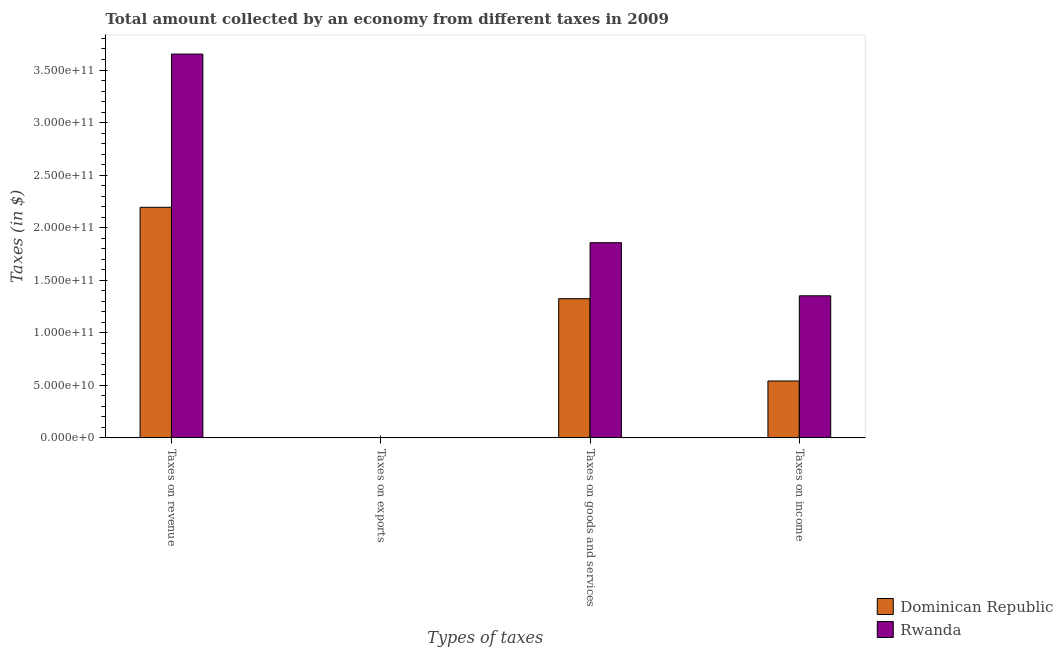How many different coloured bars are there?
Provide a succinct answer. 2. How many groups of bars are there?
Give a very brief answer. 4. Are the number of bars on each tick of the X-axis equal?
Give a very brief answer. Yes. How many bars are there on the 1st tick from the right?
Keep it short and to the point. 2. What is the label of the 1st group of bars from the left?
Provide a short and direct response. Taxes on revenue. What is the amount collected as tax on goods in Rwanda?
Provide a short and direct response. 1.86e+11. Across all countries, what is the maximum amount collected as tax on exports?
Your answer should be compact. 1.32e+08. Across all countries, what is the minimum amount collected as tax on income?
Your response must be concise. 5.41e+1. In which country was the amount collected as tax on revenue maximum?
Your response must be concise. Rwanda. In which country was the amount collected as tax on goods minimum?
Provide a short and direct response. Dominican Republic. What is the total amount collected as tax on income in the graph?
Provide a succinct answer. 1.89e+11. What is the difference between the amount collected as tax on goods in Dominican Republic and that in Rwanda?
Keep it short and to the point. -5.33e+1. What is the difference between the amount collected as tax on revenue in Dominican Republic and the amount collected as tax on exports in Rwanda?
Provide a short and direct response. 2.19e+11. What is the average amount collected as tax on revenue per country?
Your answer should be compact. 2.92e+11. What is the difference between the amount collected as tax on exports and amount collected as tax on income in Rwanda?
Make the answer very short. -1.35e+11. In how many countries, is the amount collected as tax on revenue greater than 120000000000 $?
Your answer should be compact. 2. What is the ratio of the amount collected as tax on revenue in Dominican Republic to that in Rwanda?
Provide a succinct answer. 0.6. Is the amount collected as tax on income in Rwanda less than that in Dominican Republic?
Keep it short and to the point. No. Is the difference between the amount collected as tax on income in Dominican Republic and Rwanda greater than the difference between the amount collected as tax on goods in Dominican Republic and Rwanda?
Provide a succinct answer. No. What is the difference between the highest and the second highest amount collected as tax on income?
Offer a terse response. 8.11e+1. What is the difference between the highest and the lowest amount collected as tax on goods?
Offer a very short reply. 5.33e+1. Is the sum of the amount collected as tax on goods in Rwanda and Dominican Republic greater than the maximum amount collected as tax on revenue across all countries?
Provide a succinct answer. No. Is it the case that in every country, the sum of the amount collected as tax on revenue and amount collected as tax on income is greater than the sum of amount collected as tax on goods and amount collected as tax on exports?
Offer a terse response. No. What does the 2nd bar from the left in Taxes on income represents?
Offer a very short reply. Rwanda. What does the 2nd bar from the right in Taxes on income represents?
Offer a very short reply. Dominican Republic. How many bars are there?
Offer a very short reply. 8. What is the difference between two consecutive major ticks on the Y-axis?
Your answer should be compact. 5.00e+1. Does the graph contain any zero values?
Provide a succinct answer. No. Where does the legend appear in the graph?
Your answer should be very brief. Bottom right. How are the legend labels stacked?
Your answer should be compact. Vertical. What is the title of the graph?
Offer a very short reply. Total amount collected by an economy from different taxes in 2009. Does "St. Martin (French part)" appear as one of the legend labels in the graph?
Ensure brevity in your answer.  No. What is the label or title of the X-axis?
Provide a short and direct response. Types of taxes. What is the label or title of the Y-axis?
Your answer should be compact. Taxes (in $). What is the Taxes (in $) in Dominican Republic in Taxes on revenue?
Your response must be concise. 2.19e+11. What is the Taxes (in $) in Rwanda in Taxes on revenue?
Keep it short and to the point. 3.65e+11. What is the Taxes (in $) in Dominican Republic in Taxes on exports?
Your response must be concise. 1.32e+08. What is the Taxes (in $) in Rwanda in Taxes on exports?
Your response must be concise. 1.73e+07. What is the Taxes (in $) in Dominican Republic in Taxes on goods and services?
Offer a very short reply. 1.32e+11. What is the Taxes (in $) of Rwanda in Taxes on goods and services?
Ensure brevity in your answer.  1.86e+11. What is the Taxes (in $) of Dominican Republic in Taxes on income?
Your response must be concise. 5.41e+1. What is the Taxes (in $) of Rwanda in Taxes on income?
Provide a short and direct response. 1.35e+11. Across all Types of taxes, what is the maximum Taxes (in $) of Dominican Republic?
Your response must be concise. 2.19e+11. Across all Types of taxes, what is the maximum Taxes (in $) in Rwanda?
Keep it short and to the point. 3.65e+11. Across all Types of taxes, what is the minimum Taxes (in $) of Dominican Republic?
Your answer should be compact. 1.32e+08. Across all Types of taxes, what is the minimum Taxes (in $) of Rwanda?
Provide a succinct answer. 1.73e+07. What is the total Taxes (in $) of Dominican Republic in the graph?
Your answer should be compact. 4.06e+11. What is the total Taxes (in $) of Rwanda in the graph?
Keep it short and to the point. 6.86e+11. What is the difference between the Taxes (in $) of Dominican Republic in Taxes on revenue and that in Taxes on exports?
Ensure brevity in your answer.  2.19e+11. What is the difference between the Taxes (in $) of Rwanda in Taxes on revenue and that in Taxes on exports?
Offer a very short reply. 3.65e+11. What is the difference between the Taxes (in $) of Dominican Republic in Taxes on revenue and that in Taxes on goods and services?
Ensure brevity in your answer.  8.70e+1. What is the difference between the Taxes (in $) in Rwanda in Taxes on revenue and that in Taxes on goods and services?
Your answer should be compact. 1.79e+11. What is the difference between the Taxes (in $) of Dominican Republic in Taxes on revenue and that in Taxes on income?
Ensure brevity in your answer.  1.65e+11. What is the difference between the Taxes (in $) in Rwanda in Taxes on revenue and that in Taxes on income?
Your answer should be very brief. 2.30e+11. What is the difference between the Taxes (in $) of Dominican Republic in Taxes on exports and that in Taxes on goods and services?
Keep it short and to the point. -1.32e+11. What is the difference between the Taxes (in $) of Rwanda in Taxes on exports and that in Taxes on goods and services?
Make the answer very short. -1.86e+11. What is the difference between the Taxes (in $) in Dominican Republic in Taxes on exports and that in Taxes on income?
Keep it short and to the point. -5.40e+1. What is the difference between the Taxes (in $) of Rwanda in Taxes on exports and that in Taxes on income?
Ensure brevity in your answer.  -1.35e+11. What is the difference between the Taxes (in $) of Dominican Republic in Taxes on goods and services and that in Taxes on income?
Your answer should be very brief. 7.83e+1. What is the difference between the Taxes (in $) in Rwanda in Taxes on goods and services and that in Taxes on income?
Ensure brevity in your answer.  5.05e+1. What is the difference between the Taxes (in $) in Dominican Republic in Taxes on revenue and the Taxes (in $) in Rwanda in Taxes on exports?
Ensure brevity in your answer.  2.19e+11. What is the difference between the Taxes (in $) in Dominican Republic in Taxes on revenue and the Taxes (in $) in Rwanda in Taxes on goods and services?
Make the answer very short. 3.37e+1. What is the difference between the Taxes (in $) of Dominican Republic in Taxes on revenue and the Taxes (in $) of Rwanda in Taxes on income?
Ensure brevity in your answer.  8.42e+1. What is the difference between the Taxes (in $) in Dominican Republic in Taxes on exports and the Taxes (in $) in Rwanda in Taxes on goods and services?
Your answer should be compact. -1.86e+11. What is the difference between the Taxes (in $) in Dominican Republic in Taxes on exports and the Taxes (in $) in Rwanda in Taxes on income?
Ensure brevity in your answer.  -1.35e+11. What is the difference between the Taxes (in $) of Dominican Republic in Taxes on goods and services and the Taxes (in $) of Rwanda in Taxes on income?
Offer a very short reply. -2.77e+09. What is the average Taxes (in $) of Dominican Republic per Types of taxes?
Provide a short and direct response. 1.02e+11. What is the average Taxes (in $) in Rwanda per Types of taxes?
Your answer should be compact. 1.72e+11. What is the difference between the Taxes (in $) in Dominican Republic and Taxes (in $) in Rwanda in Taxes on revenue?
Give a very brief answer. -1.46e+11. What is the difference between the Taxes (in $) of Dominican Republic and Taxes (in $) of Rwanda in Taxes on exports?
Offer a terse response. 1.14e+08. What is the difference between the Taxes (in $) of Dominican Republic and Taxes (in $) of Rwanda in Taxes on goods and services?
Provide a succinct answer. -5.33e+1. What is the difference between the Taxes (in $) of Dominican Republic and Taxes (in $) of Rwanda in Taxes on income?
Make the answer very short. -8.11e+1. What is the ratio of the Taxes (in $) in Dominican Republic in Taxes on revenue to that in Taxes on exports?
Give a very brief answer. 1666.02. What is the ratio of the Taxes (in $) in Rwanda in Taxes on revenue to that in Taxes on exports?
Keep it short and to the point. 2.11e+04. What is the ratio of the Taxes (in $) of Dominican Republic in Taxes on revenue to that in Taxes on goods and services?
Your answer should be compact. 1.66. What is the ratio of the Taxes (in $) in Rwanda in Taxes on revenue to that in Taxes on goods and services?
Your answer should be very brief. 1.97. What is the ratio of the Taxes (in $) in Dominican Republic in Taxes on revenue to that in Taxes on income?
Offer a very short reply. 4.05. What is the ratio of the Taxes (in $) of Rwanda in Taxes on revenue to that in Taxes on income?
Offer a terse response. 2.7. What is the ratio of the Taxes (in $) in Dominican Republic in Taxes on exports to that in Taxes on income?
Your answer should be compact. 0. What is the ratio of the Taxes (in $) in Dominican Republic in Taxes on goods and services to that in Taxes on income?
Offer a very short reply. 2.45. What is the ratio of the Taxes (in $) of Rwanda in Taxes on goods and services to that in Taxes on income?
Provide a short and direct response. 1.37. What is the difference between the highest and the second highest Taxes (in $) of Dominican Republic?
Your answer should be very brief. 8.70e+1. What is the difference between the highest and the second highest Taxes (in $) in Rwanda?
Offer a terse response. 1.79e+11. What is the difference between the highest and the lowest Taxes (in $) in Dominican Republic?
Ensure brevity in your answer.  2.19e+11. What is the difference between the highest and the lowest Taxes (in $) of Rwanda?
Your answer should be compact. 3.65e+11. 